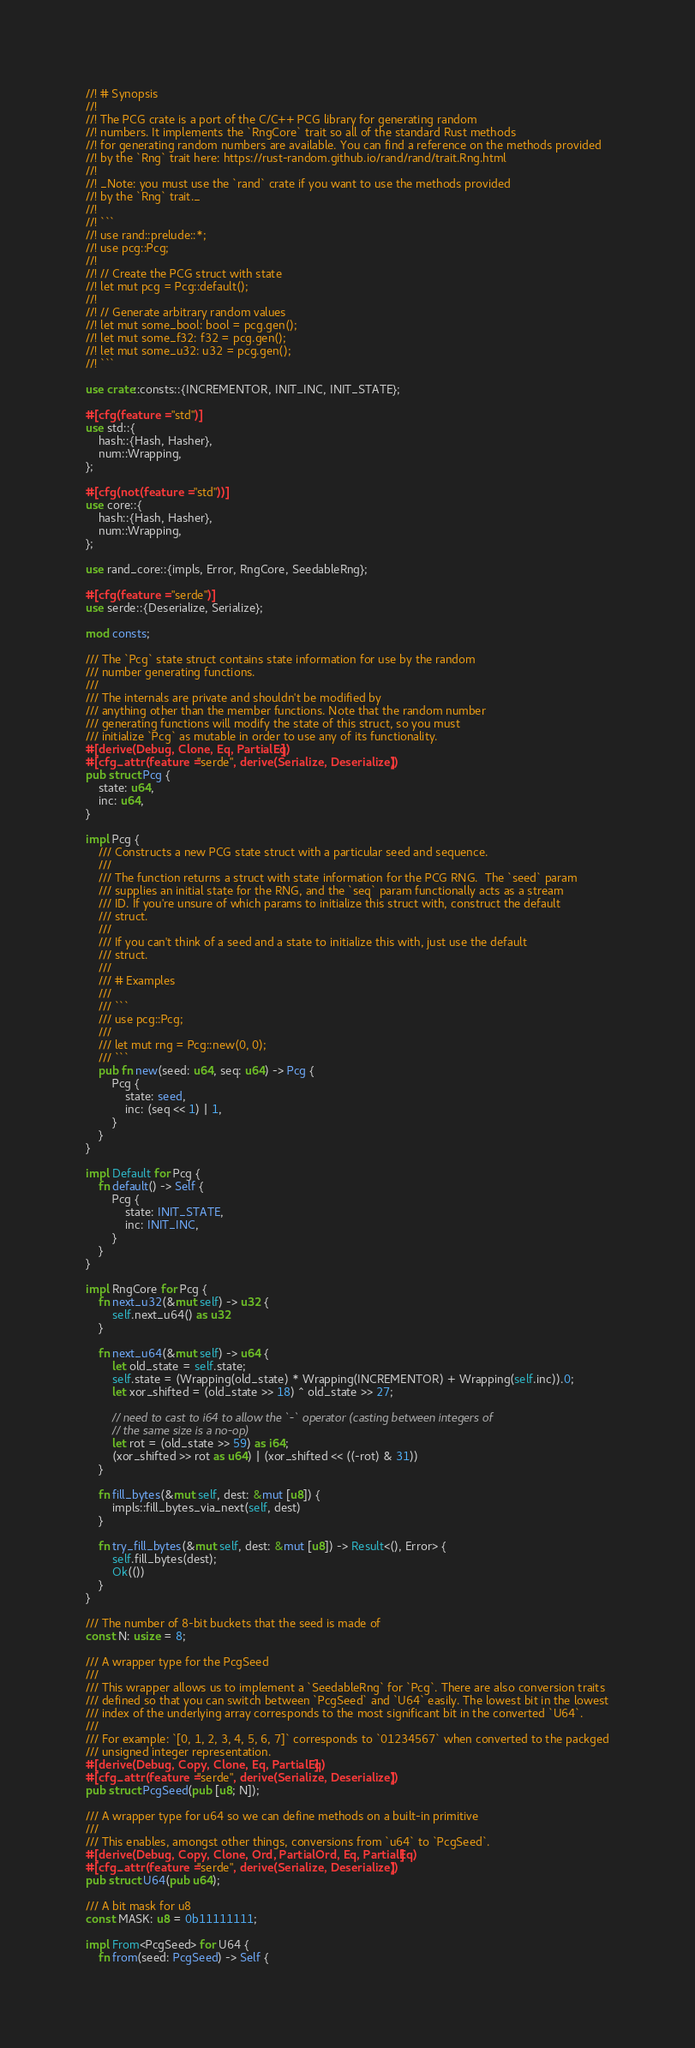Convert code to text. <code><loc_0><loc_0><loc_500><loc_500><_Rust_>//! # Synopsis
//!
//! The PCG crate is a port of the C/C++ PCG library for generating random
//! numbers. It implements the `RngCore` trait so all of the standard Rust methods
//! for generating random numbers are available. You can find a reference on the methods provided
//! by the `Rng` trait here: https://rust-random.github.io/rand/rand/trait.Rng.html
//!
//! _Note: you must use the `rand` crate if you want to use the methods provided
//! by the `Rng` trait._
//!
//! ```
//! use rand::prelude::*;
//! use pcg::Pcg;
//!
//! // Create the PCG struct with state
//! let mut pcg = Pcg::default();
//!
//! // Generate arbitrary random values
//! let mut some_bool: bool = pcg.gen();
//! let mut some_f32: f32 = pcg.gen();
//! let mut some_u32: u32 = pcg.gen();
//! ```

use crate::consts::{INCREMENTOR, INIT_INC, INIT_STATE};

#[cfg(feature = "std")]
use std::{
    hash::{Hash, Hasher},
    num::Wrapping,
};

#[cfg(not(feature = "std"))]
use core::{
    hash::{Hash, Hasher},
    num::Wrapping,
};

use rand_core::{impls, Error, RngCore, SeedableRng};

#[cfg(feature = "serde")]
use serde::{Deserialize, Serialize};

mod consts;

/// The `Pcg` state struct contains state information for use by the random
/// number generating functions.
///
/// The internals are private and shouldn't be modified by
/// anything other than the member functions. Note that the random number
/// generating functions will modify the state of this struct, so you must
/// initialize `Pcg` as mutable in order to use any of its functionality.
#[derive(Debug, Clone, Eq, PartialEq)]
#[cfg_attr(feature = "serde", derive(Serialize, Deserialize))]
pub struct Pcg {
    state: u64,
    inc: u64,
}

impl Pcg {
    /// Constructs a new PCG state struct with a particular seed and sequence.
    ///
    /// The function returns a struct with state information for the PCG RNG.  The `seed` param
    /// supplies an initial state for the RNG, and the `seq` param functionally acts as a stream
    /// ID. If you're unsure of which params to initialize this struct with, construct the default
    /// struct.
    ///
    /// If you can't think of a seed and a state to initialize this with, just use the default
    /// struct.
    ///
    /// # Examples
    ///
    /// ```
    /// use pcg::Pcg;
    ///
    /// let mut rng = Pcg::new(0, 0);
    /// ```
    pub fn new(seed: u64, seq: u64) -> Pcg {
        Pcg {
            state: seed,
            inc: (seq << 1) | 1,
        }
    }
}

impl Default for Pcg {
    fn default() -> Self {
        Pcg {
            state: INIT_STATE,
            inc: INIT_INC,
        }
    }
}

impl RngCore for Pcg {
    fn next_u32(&mut self) -> u32 {
        self.next_u64() as u32
    }

    fn next_u64(&mut self) -> u64 {
        let old_state = self.state;
        self.state = (Wrapping(old_state) * Wrapping(INCREMENTOR) + Wrapping(self.inc)).0;
        let xor_shifted = (old_state >> 18) ^ old_state >> 27;

        // need to cast to i64 to allow the `-` operator (casting between integers of
        // the same size is a no-op)
        let rot = (old_state >> 59) as i64;
        (xor_shifted >> rot as u64) | (xor_shifted << ((-rot) & 31))
    }

    fn fill_bytes(&mut self, dest: &mut [u8]) {
        impls::fill_bytes_via_next(self, dest)
    }

    fn try_fill_bytes(&mut self, dest: &mut [u8]) -> Result<(), Error> {
        self.fill_bytes(dest);
        Ok(())
    }
}

/// The number of 8-bit buckets that the seed is made of
const N: usize = 8;

/// A wrapper type for the PcgSeed
///
/// This wrapper allows us to implement a `SeedableRng` for `Pcg`. There are also conversion traits
/// defined so that you can switch between `PcgSeed` and `U64` easily. The lowest bit in the lowest
/// index of the underlying array corresponds to the most significant bit in the converted `U64`.
///
/// For example: `[0, 1, 2, 3, 4, 5, 6, 7]` corresponds to `01234567` when converted to the packged
/// unsigned integer representation.
#[derive(Debug, Copy, Clone, Eq, PartialEq)]
#[cfg_attr(feature = "serde", derive(Serialize, Deserialize))]
pub struct PcgSeed(pub [u8; N]);

/// A wrapper type for u64 so we can define methods on a built-in primitive
///
/// This enables, amongst other things, conversions from `u64` to `PcgSeed`.
#[derive(Debug, Copy, Clone, Ord, PartialOrd, Eq, PartialEq)]
#[cfg_attr(feature = "serde", derive(Serialize, Deserialize))]
pub struct U64(pub u64);

/// A bit mask for u8
const MASK: u8 = 0b11111111;

impl From<PcgSeed> for U64 {
    fn from(seed: PcgSeed) -> Self {</code> 